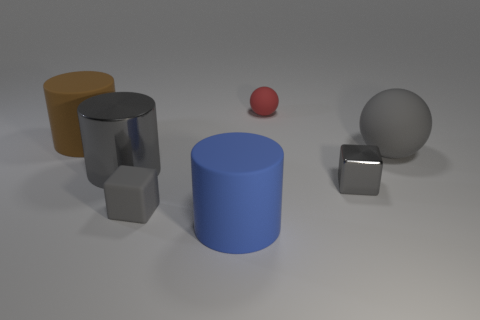Subtract all large rubber cylinders. How many cylinders are left? 1 Add 1 small rubber things. How many objects exist? 8 Subtract all red balls. How many balls are left? 1 Subtract all spheres. How many objects are left? 5 Subtract 1 balls. How many balls are left? 1 Subtract all green spheres. How many gray cylinders are left? 1 Subtract all tiny gray metal things. Subtract all small matte blocks. How many objects are left? 5 Add 2 small red things. How many small red things are left? 3 Add 7 brown things. How many brown things exist? 8 Subtract 0 red cylinders. How many objects are left? 7 